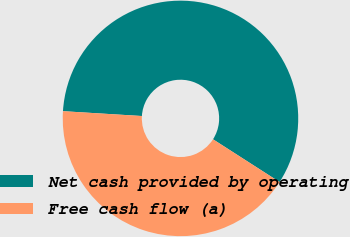Convert chart to OTSL. <chart><loc_0><loc_0><loc_500><loc_500><pie_chart><fcel>Net cash provided by operating<fcel>Free cash flow (a)<nl><fcel>58.11%<fcel>41.89%<nl></chart> 